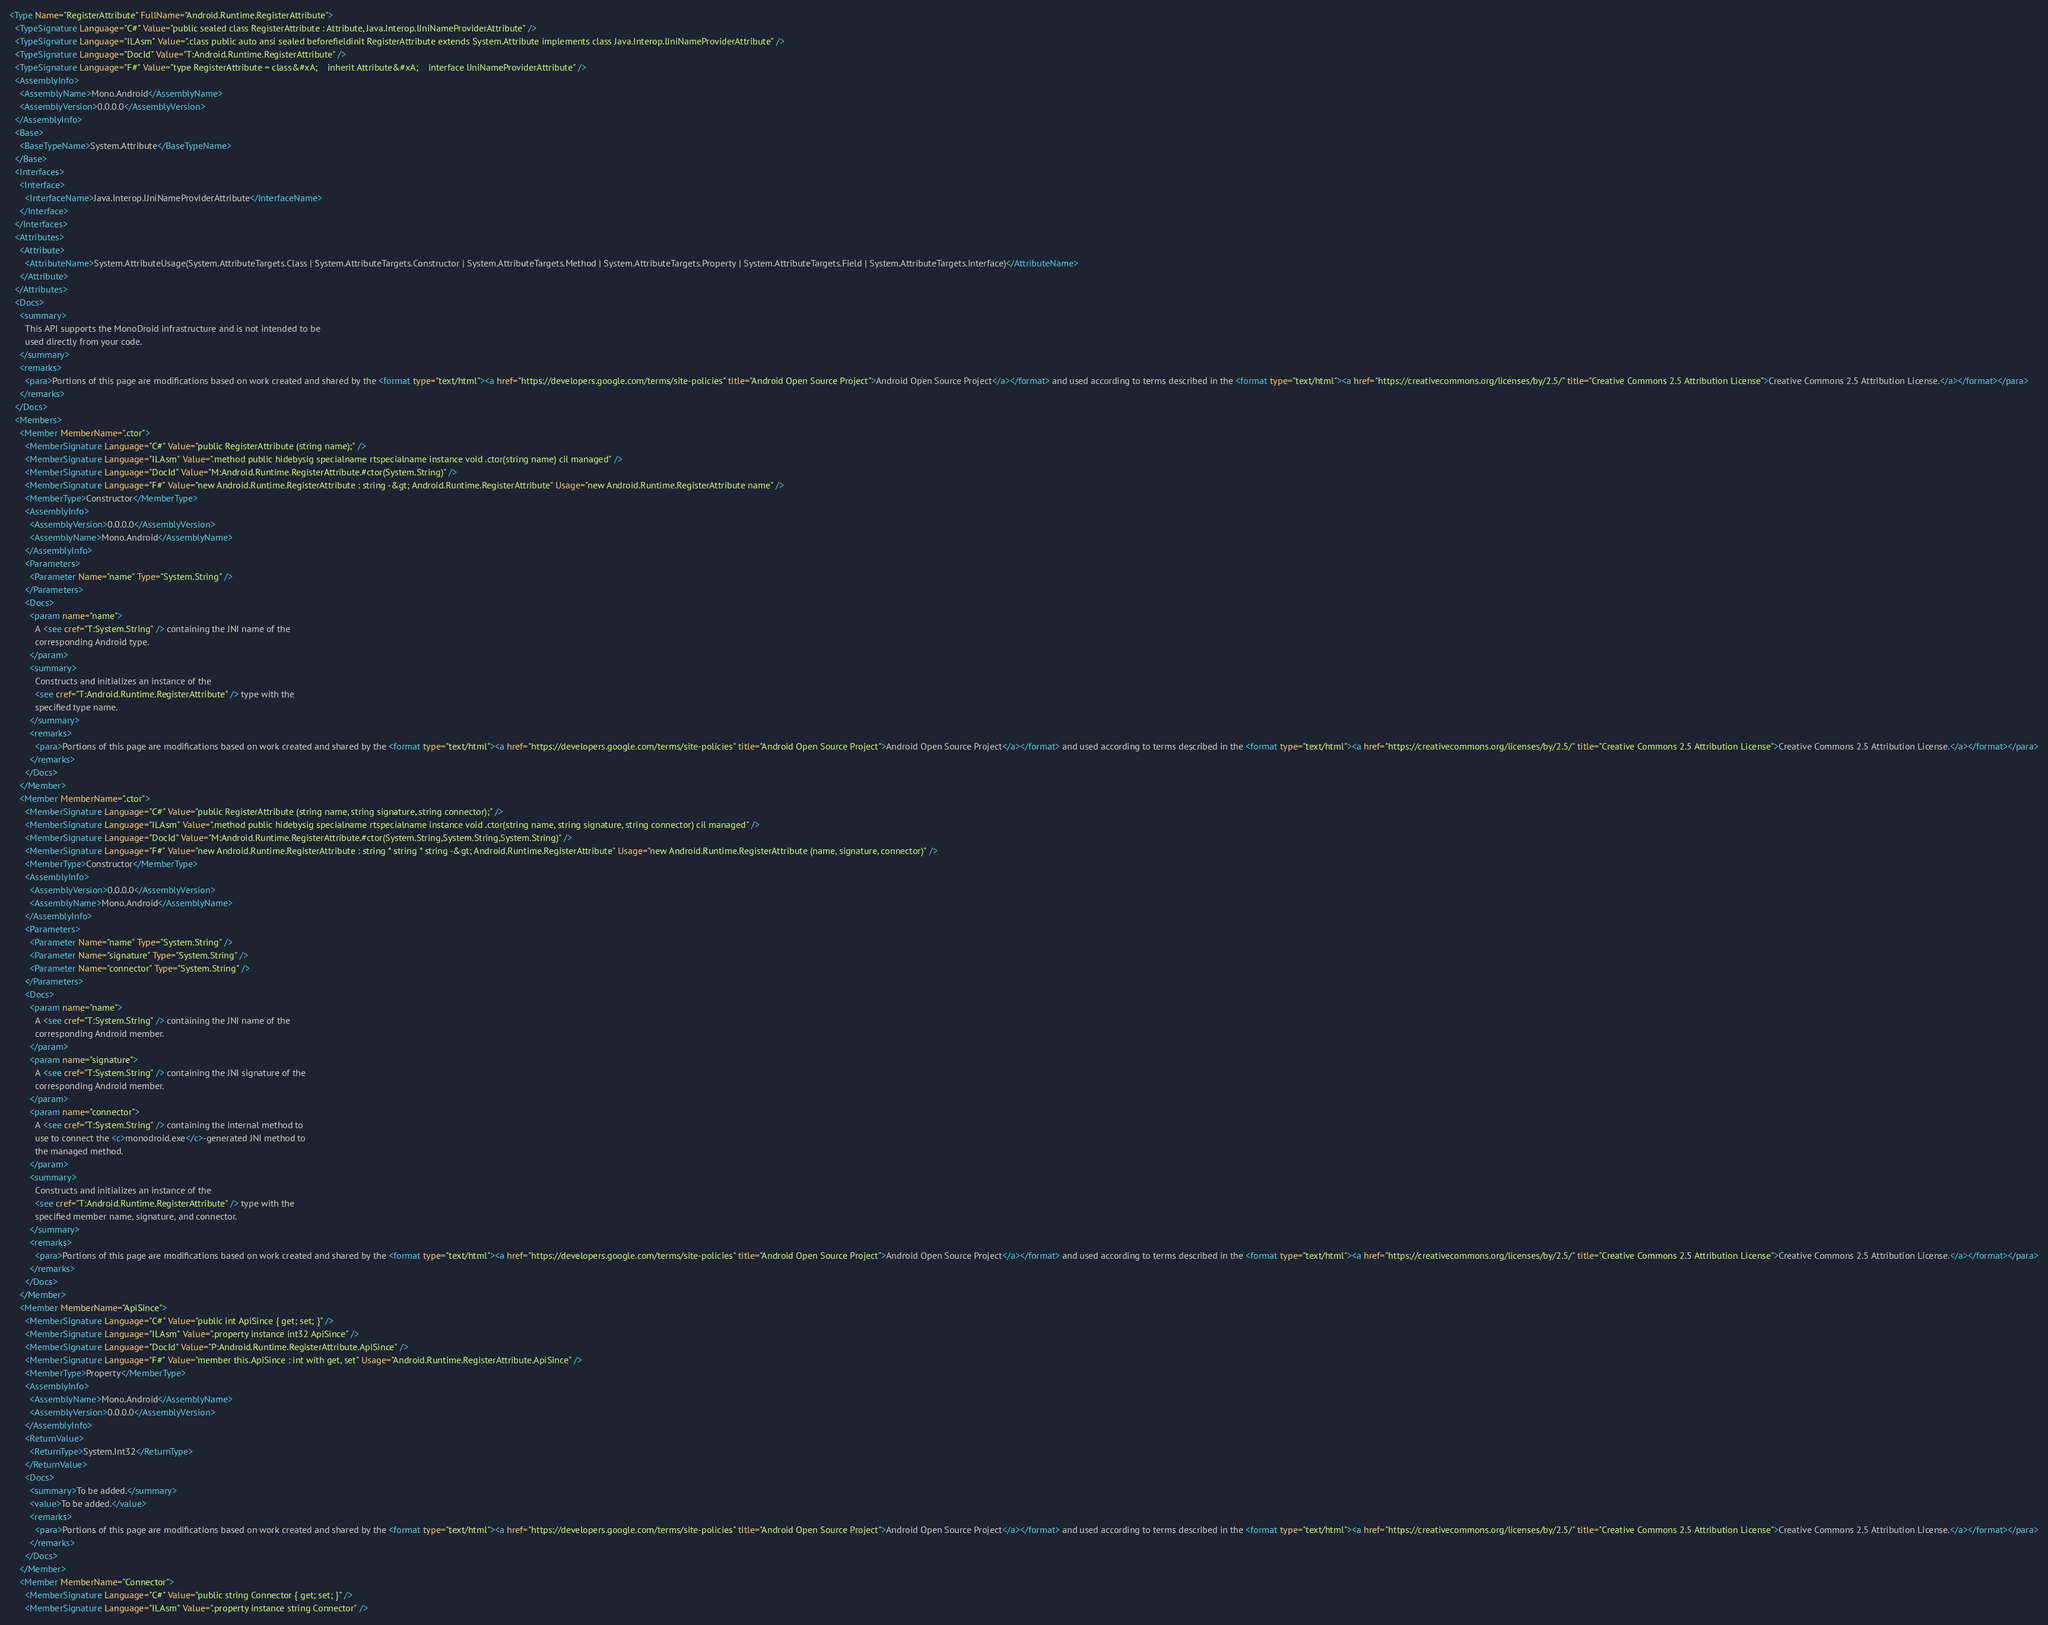Convert code to text. <code><loc_0><loc_0><loc_500><loc_500><_XML_><Type Name="RegisterAttribute" FullName="Android.Runtime.RegisterAttribute">
  <TypeSignature Language="C#" Value="public sealed class RegisterAttribute : Attribute, Java.Interop.IJniNameProviderAttribute" />
  <TypeSignature Language="ILAsm" Value=".class public auto ansi sealed beforefieldinit RegisterAttribute extends System.Attribute implements class Java.Interop.IJniNameProviderAttribute" />
  <TypeSignature Language="DocId" Value="T:Android.Runtime.RegisterAttribute" />
  <TypeSignature Language="F#" Value="type RegisterAttribute = class&#xA;    inherit Attribute&#xA;    interface IJniNameProviderAttribute" />
  <AssemblyInfo>
    <AssemblyName>Mono.Android</AssemblyName>
    <AssemblyVersion>0.0.0.0</AssemblyVersion>
  </AssemblyInfo>
  <Base>
    <BaseTypeName>System.Attribute</BaseTypeName>
  </Base>
  <Interfaces>
    <Interface>
      <InterfaceName>Java.Interop.IJniNameProviderAttribute</InterfaceName>
    </Interface>
  </Interfaces>
  <Attributes>
    <Attribute>
      <AttributeName>System.AttributeUsage(System.AttributeTargets.Class | System.AttributeTargets.Constructor | System.AttributeTargets.Method | System.AttributeTargets.Property | System.AttributeTargets.Field | System.AttributeTargets.Interface)</AttributeName>
    </Attribute>
  </Attributes>
  <Docs>
    <summary>
      This API supports the MonoDroid infrastructure and is not intended to be
      used directly from your code.
    </summary>
    <remarks>
      <para>Portions of this page are modifications based on work created and shared by the <format type="text/html"><a href="https://developers.google.com/terms/site-policies" title="Android Open Source Project">Android Open Source Project</a></format> and used according to terms described in the <format type="text/html"><a href="https://creativecommons.org/licenses/by/2.5/" title="Creative Commons 2.5 Attribution License">Creative Commons 2.5 Attribution License.</a></format></para>
    </remarks>
  </Docs>
  <Members>
    <Member MemberName=".ctor">
      <MemberSignature Language="C#" Value="public RegisterAttribute (string name);" />
      <MemberSignature Language="ILAsm" Value=".method public hidebysig specialname rtspecialname instance void .ctor(string name) cil managed" />
      <MemberSignature Language="DocId" Value="M:Android.Runtime.RegisterAttribute.#ctor(System.String)" />
      <MemberSignature Language="F#" Value="new Android.Runtime.RegisterAttribute : string -&gt; Android.Runtime.RegisterAttribute" Usage="new Android.Runtime.RegisterAttribute name" />
      <MemberType>Constructor</MemberType>
      <AssemblyInfo>
        <AssemblyVersion>0.0.0.0</AssemblyVersion>
        <AssemblyName>Mono.Android</AssemblyName>
      </AssemblyInfo>
      <Parameters>
        <Parameter Name="name" Type="System.String" />
      </Parameters>
      <Docs>
        <param name="name">
          A <see cref="T:System.String" /> containing the JNI name of the
          corresponding Android type.
        </param>
        <summary>
          Constructs and initializes an instance of the 
          <see cref="T:Android.Runtime.RegisterAttribute" /> type with the
          specified type name.
        </summary>
        <remarks>
          <para>Portions of this page are modifications based on work created and shared by the <format type="text/html"><a href="https://developers.google.com/terms/site-policies" title="Android Open Source Project">Android Open Source Project</a></format> and used according to terms described in the <format type="text/html"><a href="https://creativecommons.org/licenses/by/2.5/" title="Creative Commons 2.5 Attribution License">Creative Commons 2.5 Attribution License.</a></format></para>
        </remarks>
      </Docs>
    </Member>
    <Member MemberName=".ctor">
      <MemberSignature Language="C#" Value="public RegisterAttribute (string name, string signature, string connector);" />
      <MemberSignature Language="ILAsm" Value=".method public hidebysig specialname rtspecialname instance void .ctor(string name, string signature, string connector) cil managed" />
      <MemberSignature Language="DocId" Value="M:Android.Runtime.RegisterAttribute.#ctor(System.String,System.String,System.String)" />
      <MemberSignature Language="F#" Value="new Android.Runtime.RegisterAttribute : string * string * string -&gt; Android.Runtime.RegisterAttribute" Usage="new Android.Runtime.RegisterAttribute (name, signature, connector)" />
      <MemberType>Constructor</MemberType>
      <AssemblyInfo>
        <AssemblyVersion>0.0.0.0</AssemblyVersion>
        <AssemblyName>Mono.Android</AssemblyName>
      </AssemblyInfo>
      <Parameters>
        <Parameter Name="name" Type="System.String" />
        <Parameter Name="signature" Type="System.String" />
        <Parameter Name="connector" Type="System.String" />
      </Parameters>
      <Docs>
        <param name="name">
          A <see cref="T:System.String" /> containing the JNI name of the
          corresponding Android member.
        </param>
        <param name="signature">
          A <see cref="T:System.String" /> containing the JNI signature of the 
          corresponding Android member.
        </param>
        <param name="connector">
          A <see cref="T:System.String" /> containing the internal method to
          use to connect the <c>monodroid.exe</c>-generated JNI method to 
          the managed method.
        </param>
        <summary>
          Constructs and initializes an instance of the 
          <see cref="T:Android.Runtime.RegisterAttribute" /> type with the
          specified member name, signature, and connector.
        </summary>
        <remarks>
          <para>Portions of this page are modifications based on work created and shared by the <format type="text/html"><a href="https://developers.google.com/terms/site-policies" title="Android Open Source Project">Android Open Source Project</a></format> and used according to terms described in the <format type="text/html"><a href="https://creativecommons.org/licenses/by/2.5/" title="Creative Commons 2.5 Attribution License">Creative Commons 2.5 Attribution License.</a></format></para>
        </remarks>
      </Docs>
    </Member>
    <Member MemberName="ApiSince">
      <MemberSignature Language="C#" Value="public int ApiSince { get; set; }" />
      <MemberSignature Language="ILAsm" Value=".property instance int32 ApiSince" />
      <MemberSignature Language="DocId" Value="P:Android.Runtime.RegisterAttribute.ApiSince" />
      <MemberSignature Language="F#" Value="member this.ApiSince : int with get, set" Usage="Android.Runtime.RegisterAttribute.ApiSince" />
      <MemberType>Property</MemberType>
      <AssemblyInfo>
        <AssemblyName>Mono.Android</AssemblyName>
        <AssemblyVersion>0.0.0.0</AssemblyVersion>
      </AssemblyInfo>
      <ReturnValue>
        <ReturnType>System.Int32</ReturnType>
      </ReturnValue>
      <Docs>
        <summary>To be added.</summary>
        <value>To be added.</value>
        <remarks>
          <para>Portions of this page are modifications based on work created and shared by the <format type="text/html"><a href="https://developers.google.com/terms/site-policies" title="Android Open Source Project">Android Open Source Project</a></format> and used according to terms described in the <format type="text/html"><a href="https://creativecommons.org/licenses/by/2.5/" title="Creative Commons 2.5 Attribution License">Creative Commons 2.5 Attribution License.</a></format></para>
        </remarks>
      </Docs>
    </Member>
    <Member MemberName="Connector">
      <MemberSignature Language="C#" Value="public string Connector { get; set; }" />
      <MemberSignature Language="ILAsm" Value=".property instance string Connector" /></code> 